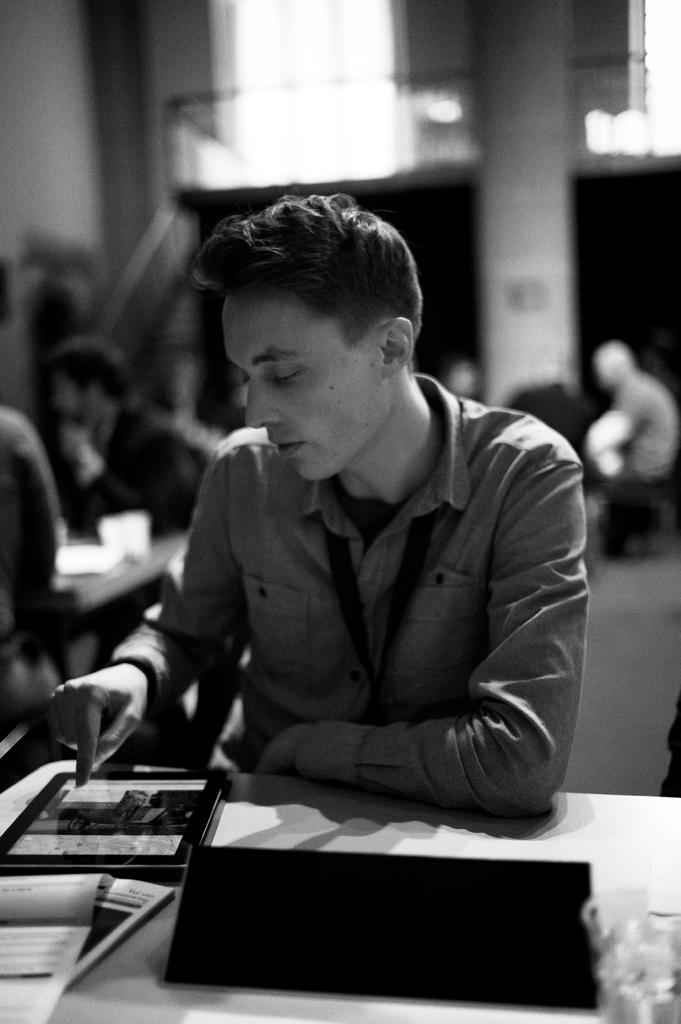Who is the main subject in the image? There is a man in the image. What is the man's position in relation to the table? The man is in front of a table. What can be found on the table? There are things on the table. Can you describe the setting in the background of the image? There are people in the background of the image. What type of seed is the man planting in the image? There is no seed or planting activity present in the image. What is the man writing on the table in the image? There is no writing or writer mentioned in the image. 